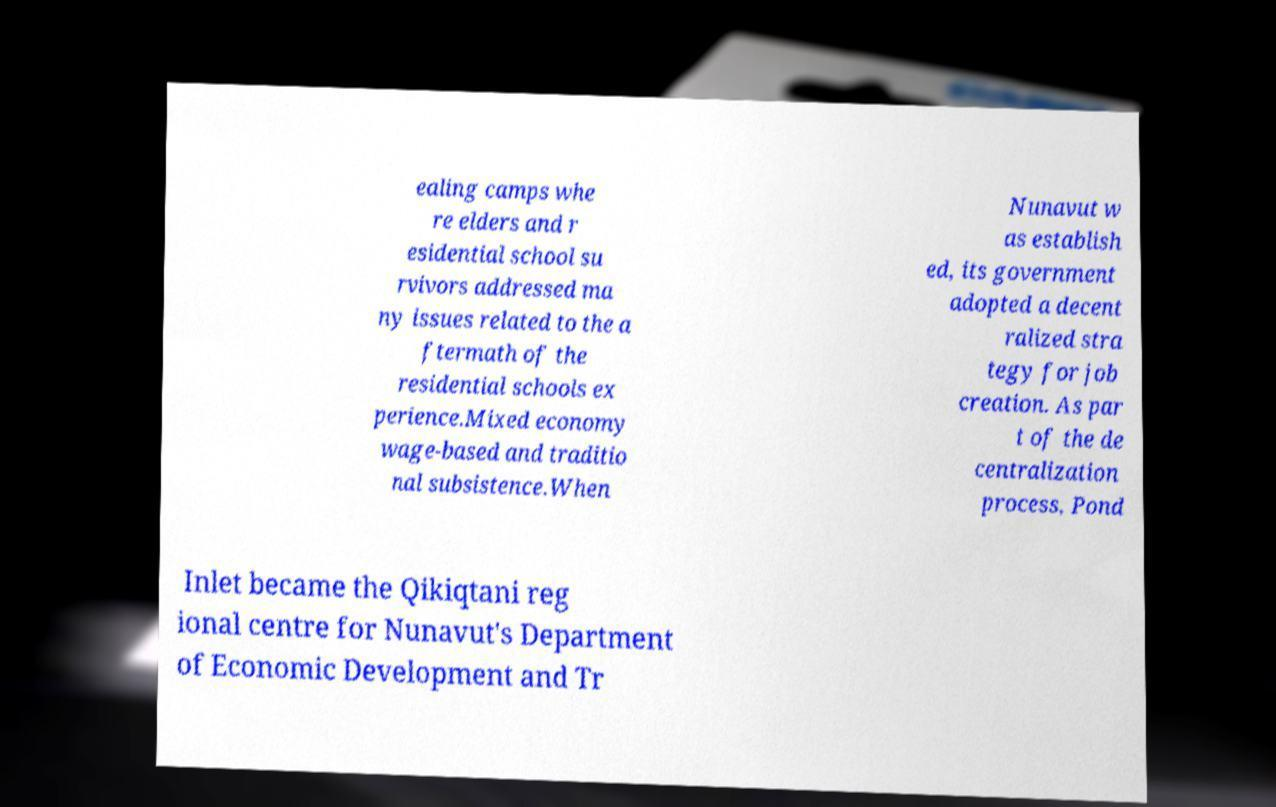Please identify and transcribe the text found in this image. ealing camps whe re elders and r esidential school su rvivors addressed ma ny issues related to the a ftermath of the residential schools ex perience.Mixed economy wage-based and traditio nal subsistence.When Nunavut w as establish ed, its government adopted a decent ralized stra tegy for job creation. As par t of the de centralization process, Pond Inlet became the Qikiqtani reg ional centre for Nunavut's Department of Economic Development and Tr 